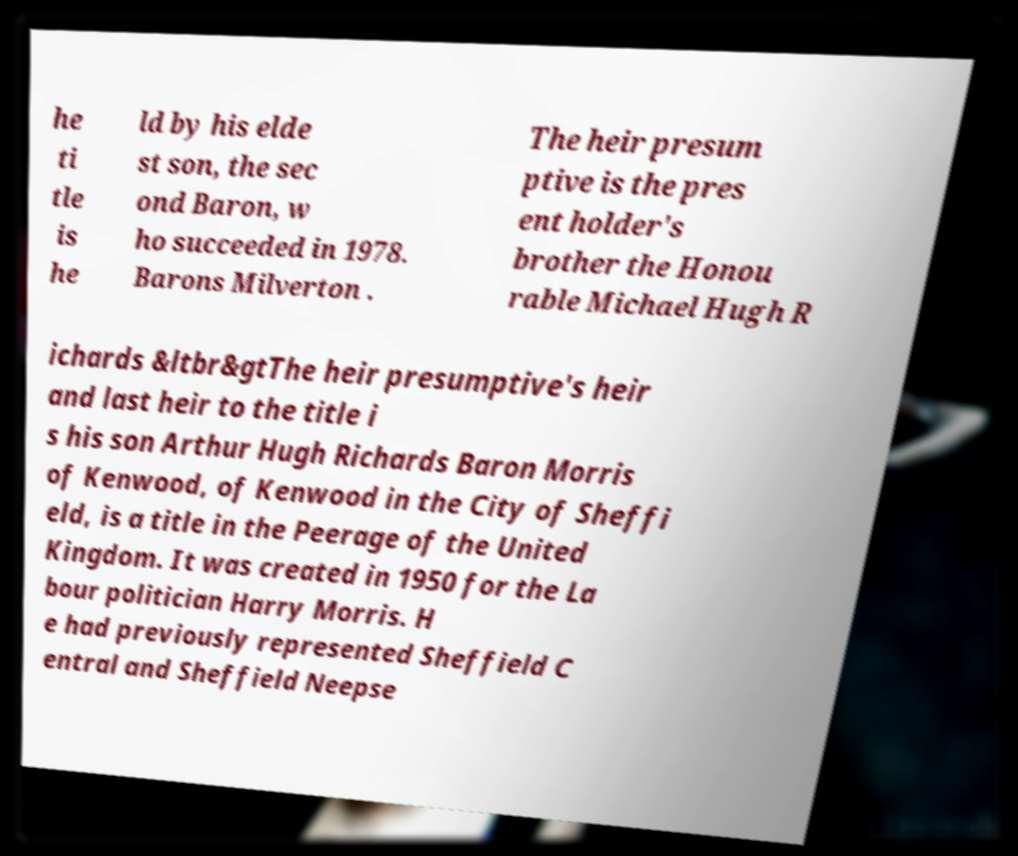Can you accurately transcribe the text from the provided image for me? he ti tle is he ld by his elde st son, the sec ond Baron, w ho succeeded in 1978. Barons Milverton . The heir presum ptive is the pres ent holder's brother the Honou rable Michael Hugh R ichards &ltbr&gtThe heir presumptive's heir and last heir to the title i s his son Arthur Hugh Richards Baron Morris of Kenwood, of Kenwood in the City of Sheffi eld, is a title in the Peerage of the United Kingdom. It was created in 1950 for the La bour politician Harry Morris. H e had previously represented Sheffield C entral and Sheffield Neepse 